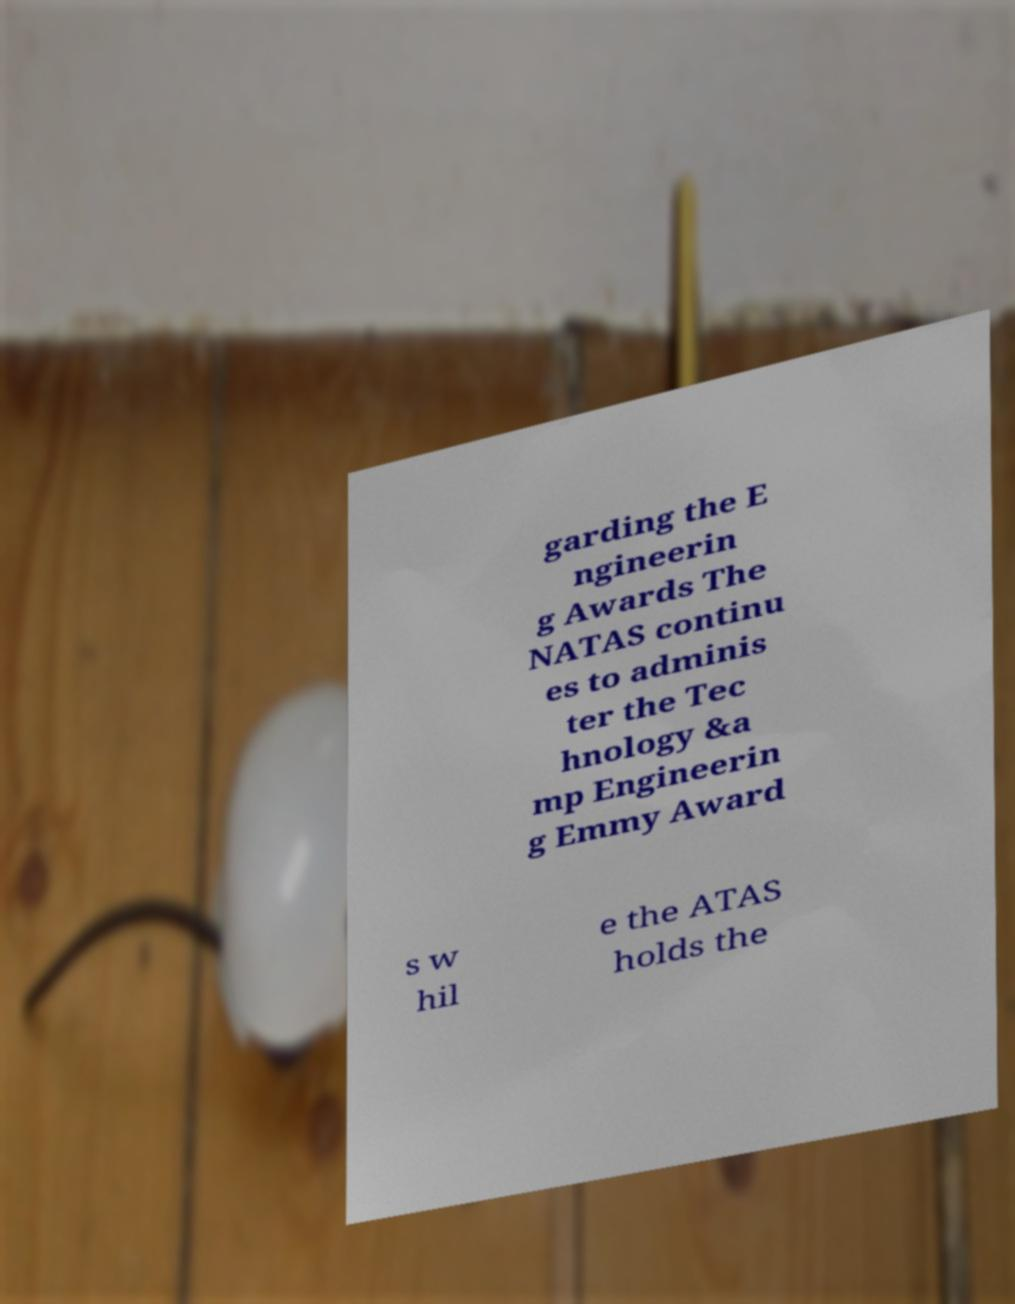For documentation purposes, I need the text within this image transcribed. Could you provide that? garding the E ngineerin g Awards The NATAS continu es to adminis ter the Tec hnology &a mp Engineerin g Emmy Award s w hil e the ATAS holds the 